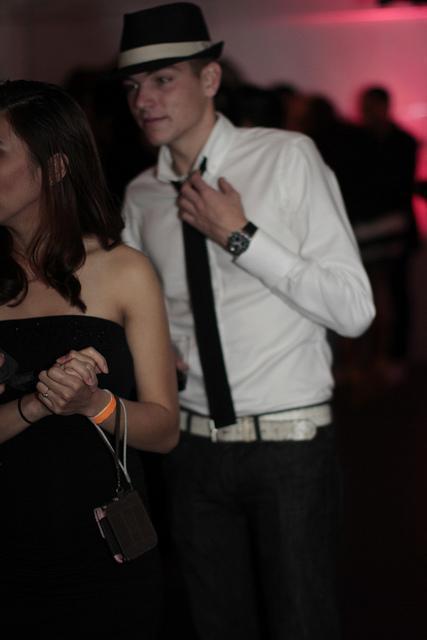How many people are in the picture?
Give a very brief answer. 3. How many horses are shown?
Give a very brief answer. 0. 